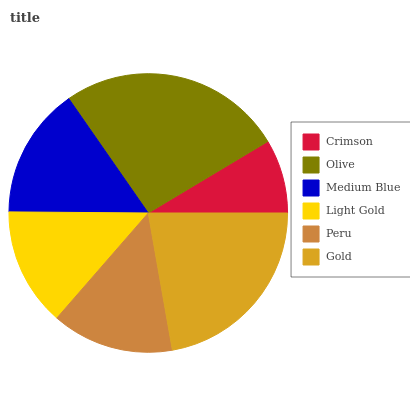Is Crimson the minimum?
Answer yes or no. Yes. Is Olive the maximum?
Answer yes or no. Yes. Is Medium Blue the minimum?
Answer yes or no. No. Is Medium Blue the maximum?
Answer yes or no. No. Is Olive greater than Medium Blue?
Answer yes or no. Yes. Is Medium Blue less than Olive?
Answer yes or no. Yes. Is Medium Blue greater than Olive?
Answer yes or no. No. Is Olive less than Medium Blue?
Answer yes or no. No. Is Medium Blue the high median?
Answer yes or no. Yes. Is Peru the low median?
Answer yes or no. Yes. Is Crimson the high median?
Answer yes or no. No. Is Gold the low median?
Answer yes or no. No. 